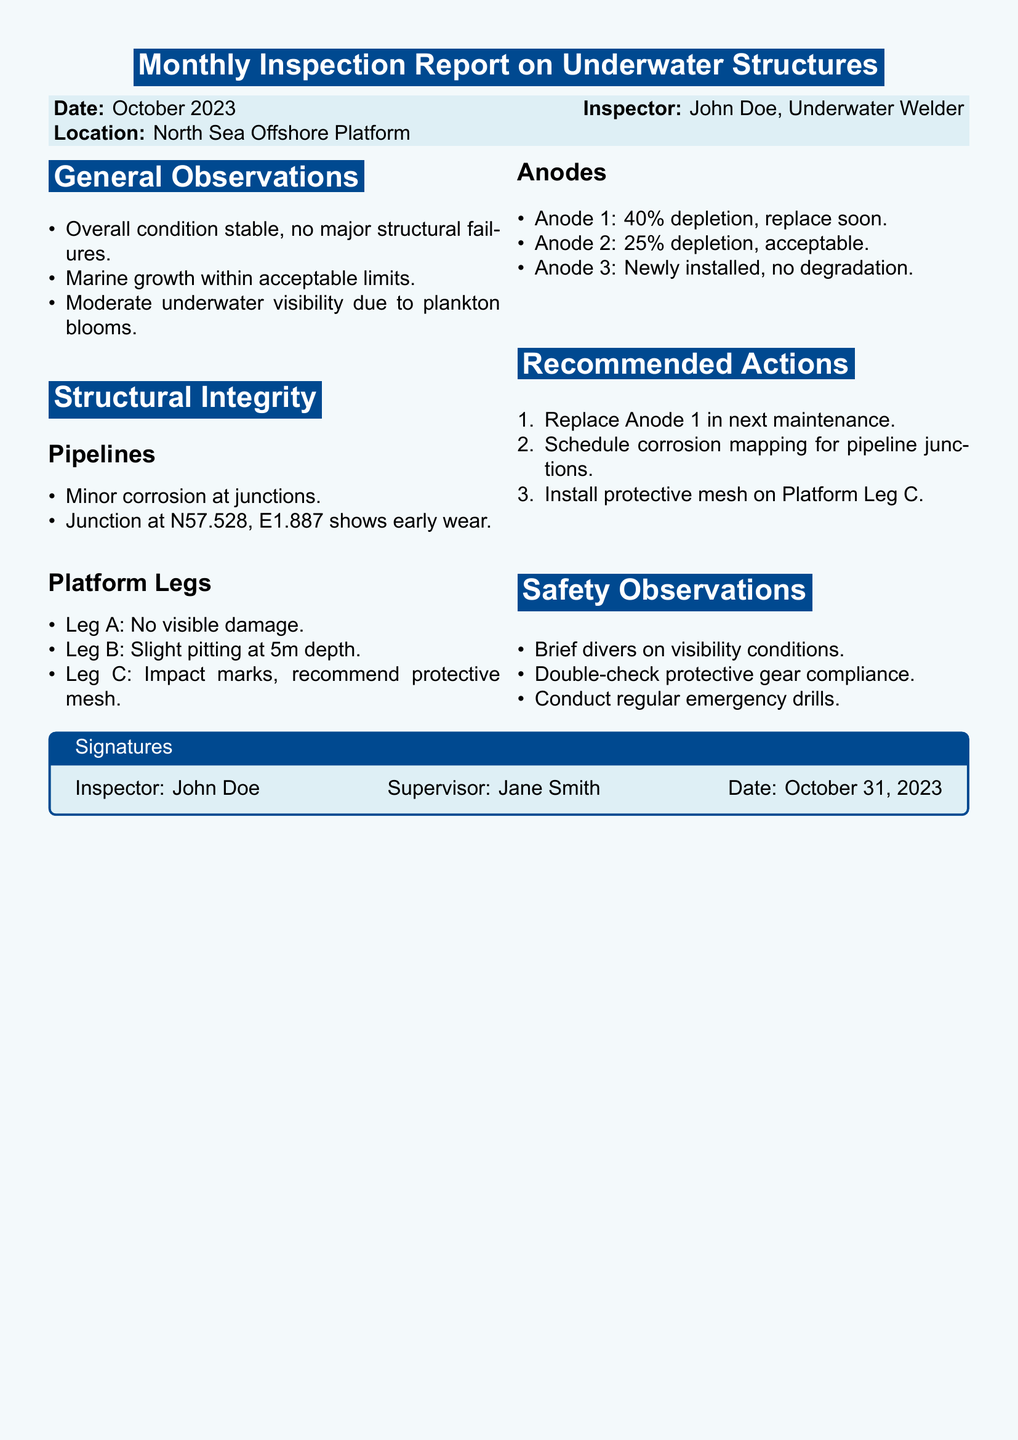What is the date of the inspection? The date of the inspection is stated in the report header.
Answer: October 2023 What is the name of the inspector? The inspector's name is mentioned in the report header.
Answer: John Doe What is the location of the inspection? The location is provided in the report header section.
Answer: North Sea Offshore Platform What percentage of depletion is Anode 1 at? The depletion percentage for Anode 1 is specified in the anodes section.
Answer: 40% What is recommended for Platform Leg C? The recommendation section specifies actions for Platform Leg C.
Answer: Install protective mesh What is the overall condition reported? The general observations provide the status of the overall condition.
Answer: Stable What were the visibility conditions during the inspection? The safety observations highlight the visibility issues.
Answer: Moderate What is the recommendation for pipeline junctions? The recommendations include actions for pipeline junctions.
Answer: Schedule corrosion mapping What is the state of Leg B? The structural integrity section details the condition of Leg B.
Answer: Slight pitting 